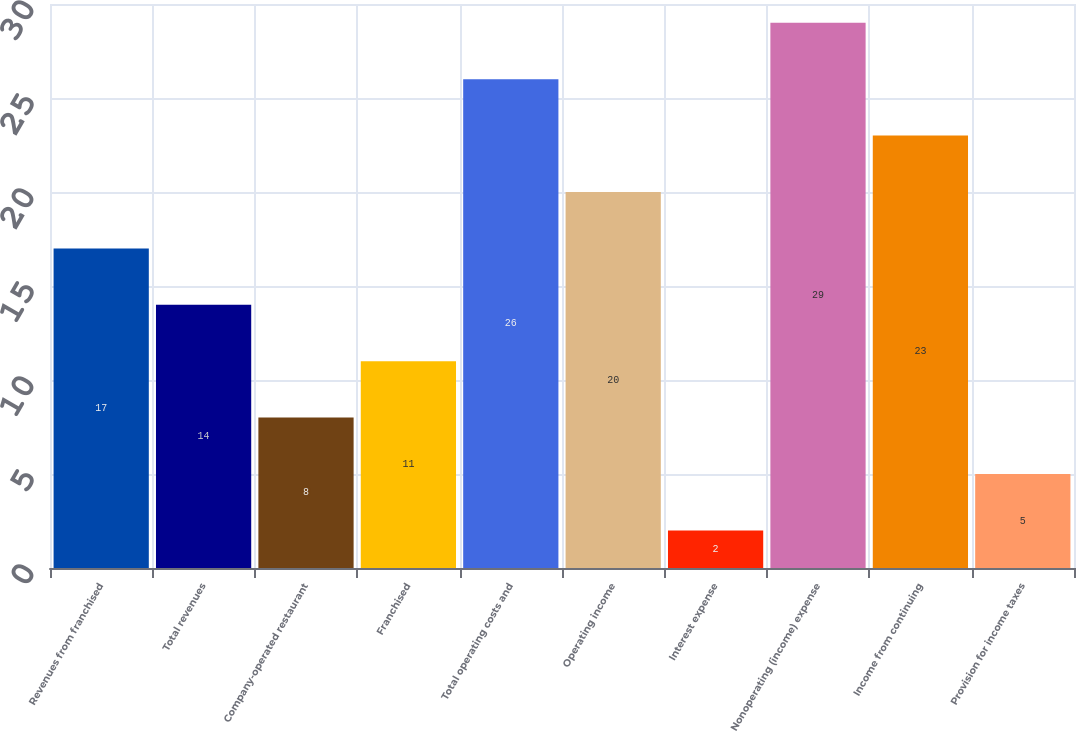Convert chart. <chart><loc_0><loc_0><loc_500><loc_500><bar_chart><fcel>Revenues from franchised<fcel>Total revenues<fcel>Company-operated restaurant<fcel>Franchised<fcel>Total operating costs and<fcel>Operating income<fcel>Interest expense<fcel>Nonoperating (income) expense<fcel>Income from continuing<fcel>Provision for income taxes<nl><fcel>17<fcel>14<fcel>8<fcel>11<fcel>26<fcel>20<fcel>2<fcel>29<fcel>23<fcel>5<nl></chart> 